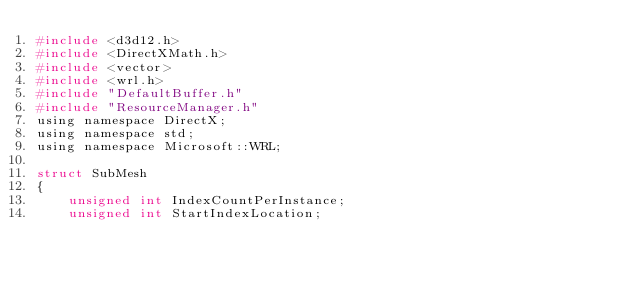Convert code to text. <code><loc_0><loc_0><loc_500><loc_500><_C_>#include <d3d12.h>
#include <DirectXMath.h>
#include <vector>
#include <wrl.h>
#include "DefaultBuffer.h"
#include "ResourceManager.h"
using namespace DirectX;
using namespace std;
using namespace Microsoft::WRL;

struct SubMesh
{
	unsigned int IndexCountPerInstance;
	unsigned int StartIndexLocation;</code> 